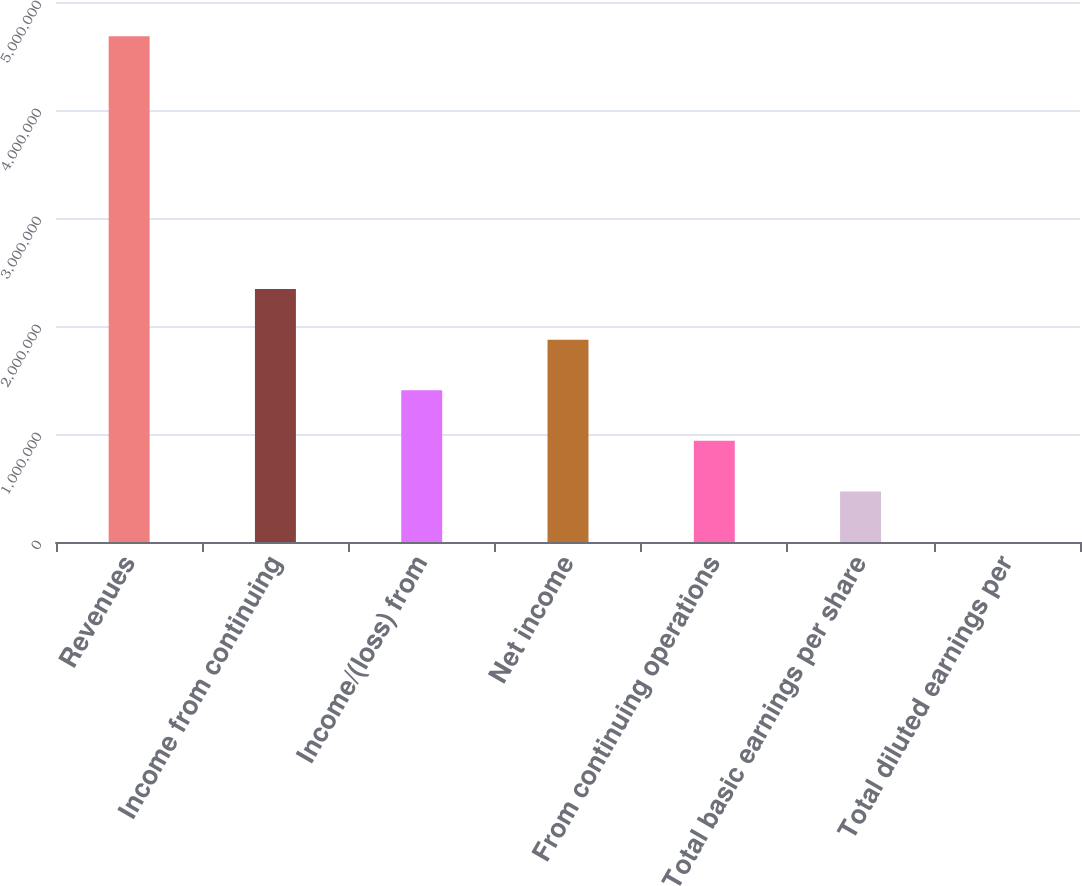<chart> <loc_0><loc_0><loc_500><loc_500><bar_chart><fcel>Revenues<fcel>Income from continuing<fcel>Income/(loss) from<fcel>Net income<fcel>From continuing operations<fcel>Total basic earnings per share<fcel>Total diluted earnings per<nl><fcel>4.68315e+06<fcel>2.34158e+06<fcel>1.40495e+06<fcel>1.87326e+06<fcel>936633<fcel>468318<fcel>3.18<nl></chart> 